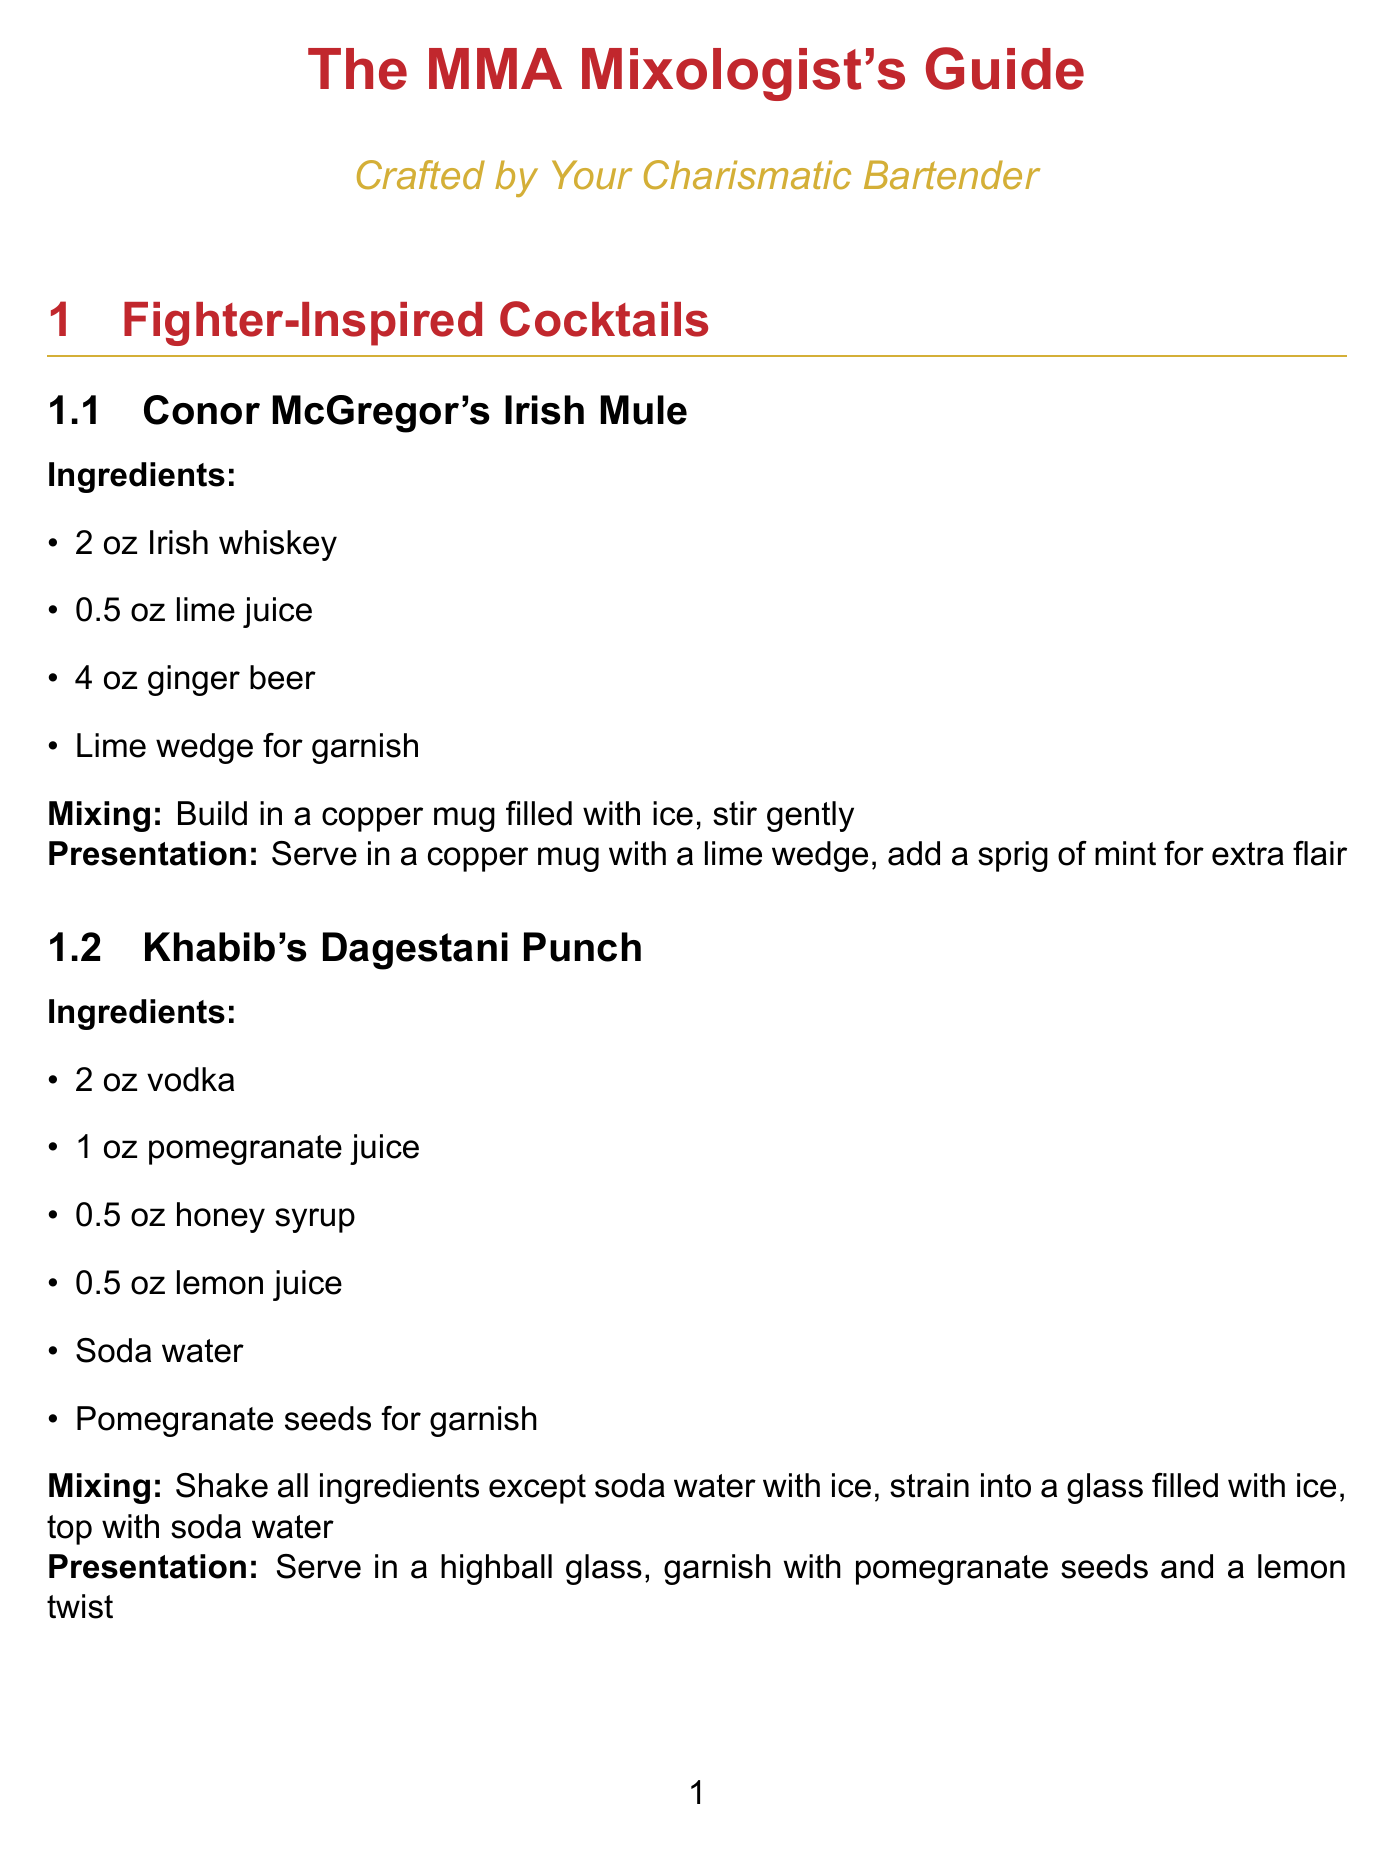What is the main title of the document? The main title is stated in the document at the beginning, which summarizes the content of the report related to cocktail recipes and mixing techniques.
Answer: The MMA Mixologist's Guide Name one cocktail recipe inspired by a fighter. Several cocktail recipes are listed that are inspired by MMA fighters, which exemplify their personalities or styles.
Answer: Conor McGregor's Irish Mule What is the mixing technique for Khabib's Dagestani Punch? The method used for mixing this cocktail is directly mentioned in its recipe details from the document.
Answer: Shake all ingredients except soda water with ice, strain into a glass filled with ice, top with soda water How many ingredients are used in Nate Diaz's Stockton Slap? The number of ingredients required for this cocktail is specified in the recipe section where the ingredients are listed.
Answer: Five What type of glass is suggested for serving Conor McGregor's Irish Mule? The presentation section of the recipe outlines the type of glassware in which this drink should be served.
Answer: Copper mug What is a pro tip for the shaking technique? A specific tip is provided in the mixing techniques section to enhance the shaking process for cocktails with egg whites.
Answer: Use the 'dry shake' technique for egg white cocktails How should glasses be prepared before serving cocktails? The document offers a best practice for the preparation of glassware in the presentation tips section to improve the drinking experience.
Answer: Chill glasses before serving Which bar tool is used to strain shaken cocktails? The tool that serves this purpose is highlighted in the essential bar tools section, indicating its specific use in cocktail making.
Answer: Hawthorne strainer 